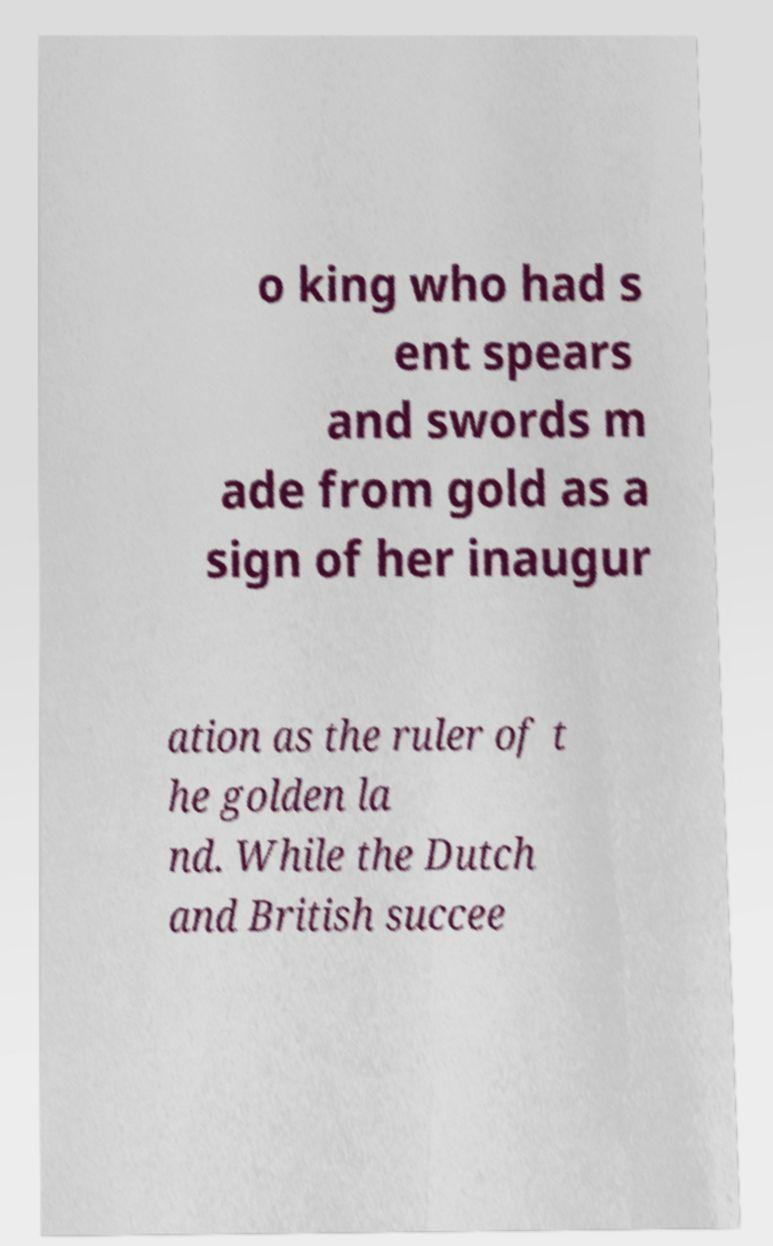Please read and relay the text visible in this image. What does it say? o king who had s ent spears and swords m ade from gold as a sign of her inaugur ation as the ruler of t he golden la nd. While the Dutch and British succee 